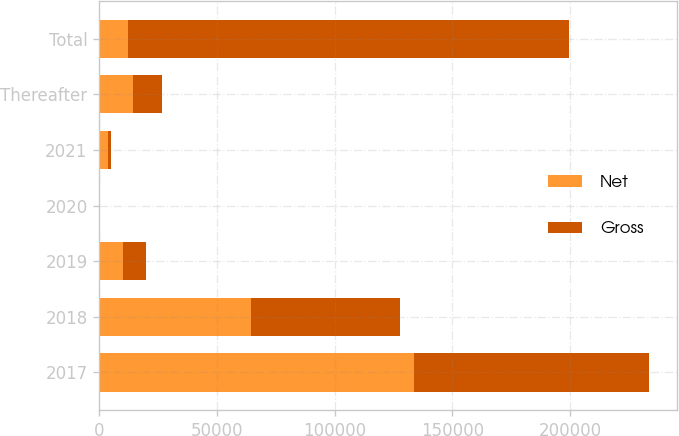Convert chart. <chart><loc_0><loc_0><loc_500><loc_500><stacked_bar_chart><ecel><fcel>2017<fcel>2018<fcel>2019<fcel>2020<fcel>2021<fcel>Thereafter<fcel>Total<nl><fcel>Net<fcel>133558<fcel>64490<fcel>9981<fcel>160<fcel>3564<fcel>14288<fcel>12338<nl><fcel>Gross<fcel>100129<fcel>63122<fcel>9981<fcel>160<fcel>1300<fcel>12338<fcel>187030<nl></chart> 